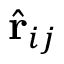Convert formula to latex. <formula><loc_0><loc_0><loc_500><loc_500>{ \hat { r } } _ { i j }</formula> 